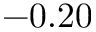Convert formula to latex. <formula><loc_0><loc_0><loc_500><loc_500>- 0 . 2 0</formula> 